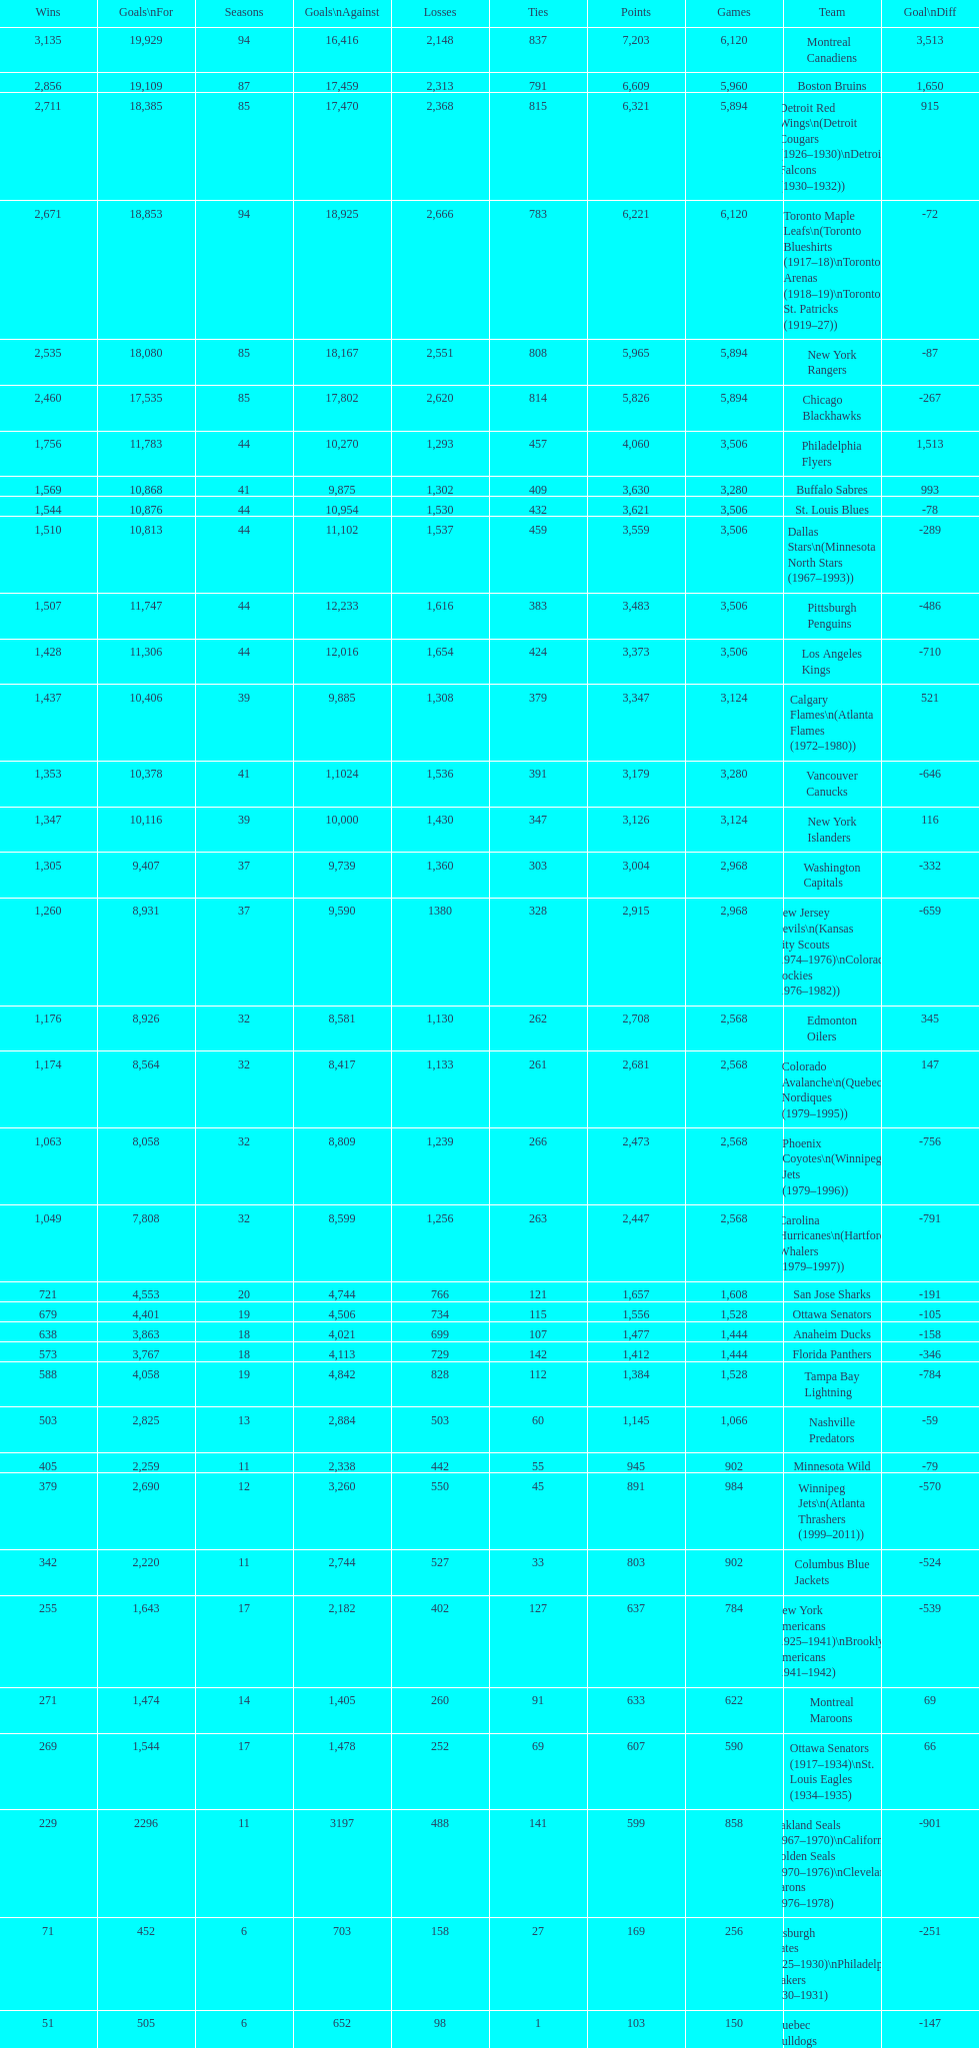How many total points has the lost angeles kings scored? 3,373. 